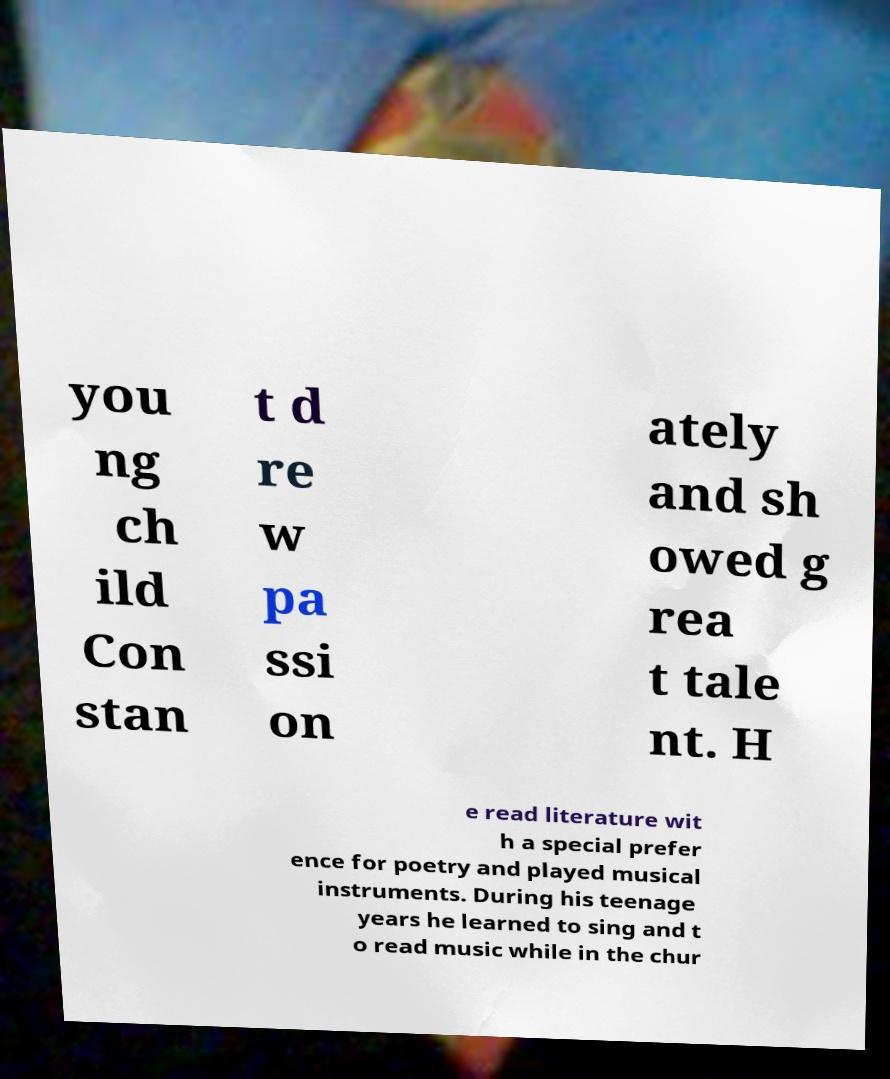Please read and relay the text visible in this image. What does it say? you ng ch ild Con stan t d re w pa ssi on ately and sh owed g rea t tale nt. H e read literature wit h a special prefer ence for poetry and played musical instruments. During his teenage years he learned to sing and t o read music while in the chur 